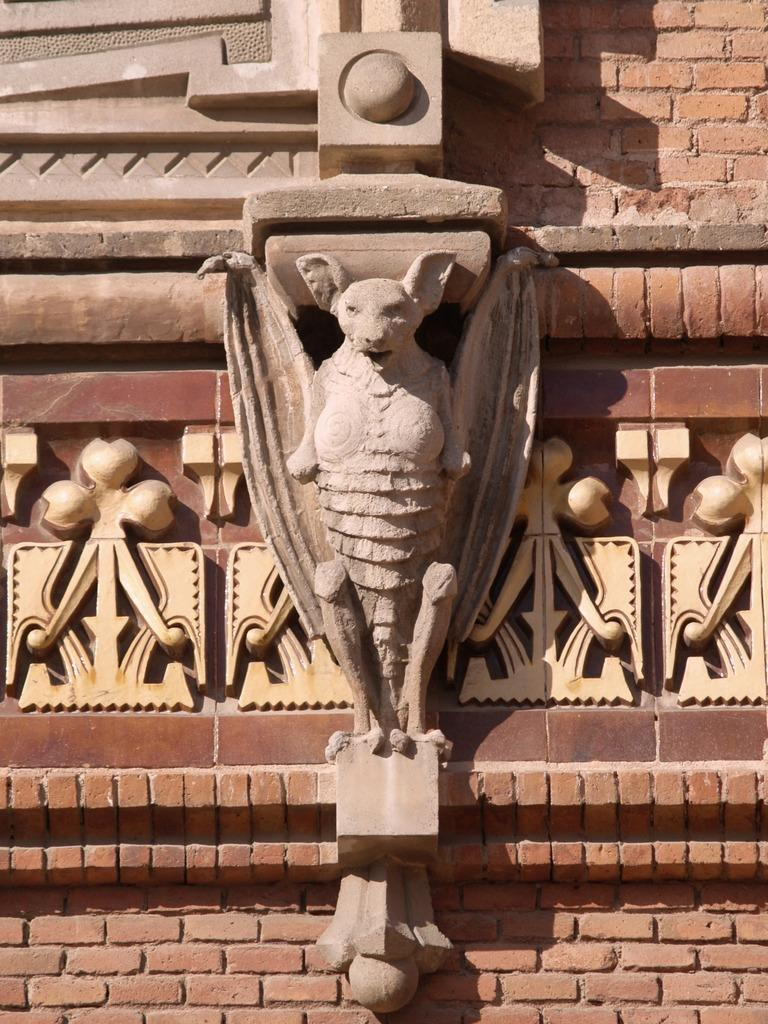What can be seen carved on the wall in the image? There is a structure of an animal carved on the wall in the image. Can you describe the animal that is carved on the wall? Unfortunately, the specific animal cannot be determined from the image alone. What type of material might the wall be made of, based on the carving? The material of the wall cannot be determined from the image alone. How many stitches are used to create the tail of the animal in the image? There is no tail visible in the image, as the animal carving does not have a tail. 